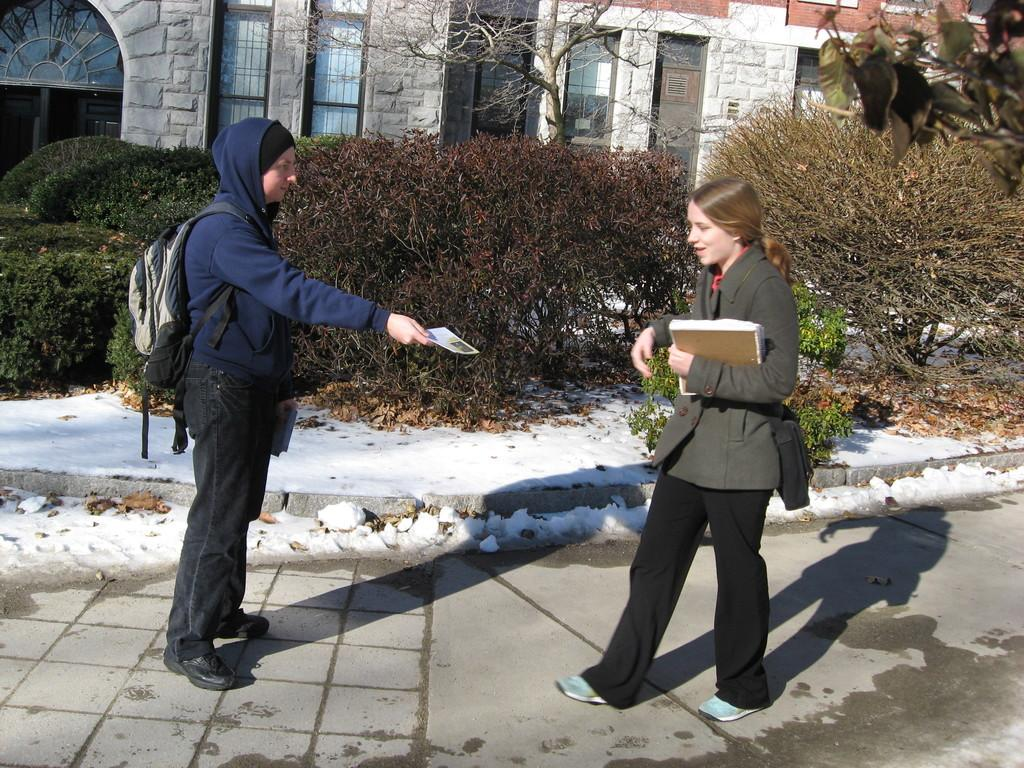What type of structures can be seen in the image? There are buildings in the image. What architectural feature is present in the buildings? There are windows in the image. What type of vegetation is present in the image? There are plants and dry trees in the image. What is one person holding in the image? One person is wearing a bag and holding something. What is the other person holding in the image? The other person is holding a book. What color is the dirt on the person's shoes in the image? There is no dirt or shoes mentioned in the image; it only describes buildings, windows, plants, and people holding items. 